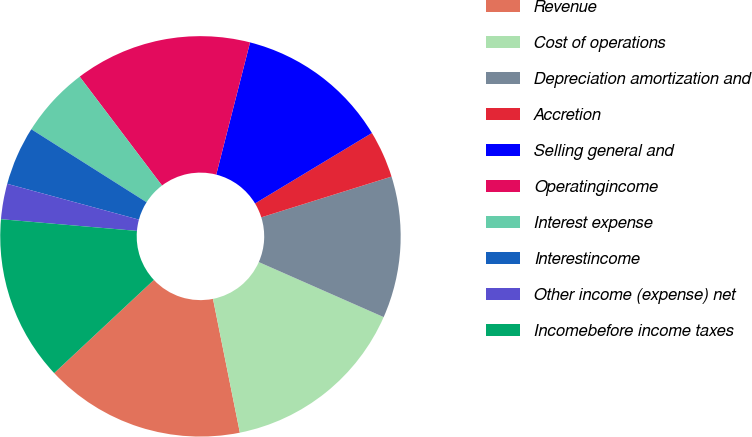Convert chart. <chart><loc_0><loc_0><loc_500><loc_500><pie_chart><fcel>Revenue<fcel>Cost of operations<fcel>Depreciation amortization and<fcel>Accretion<fcel>Selling general and<fcel>Operatingincome<fcel>Interest expense<fcel>Interestincome<fcel>Other income (expense) net<fcel>Incomebefore income taxes<nl><fcel>16.19%<fcel>15.24%<fcel>11.43%<fcel>3.81%<fcel>12.38%<fcel>14.29%<fcel>5.71%<fcel>4.76%<fcel>2.86%<fcel>13.33%<nl></chart> 